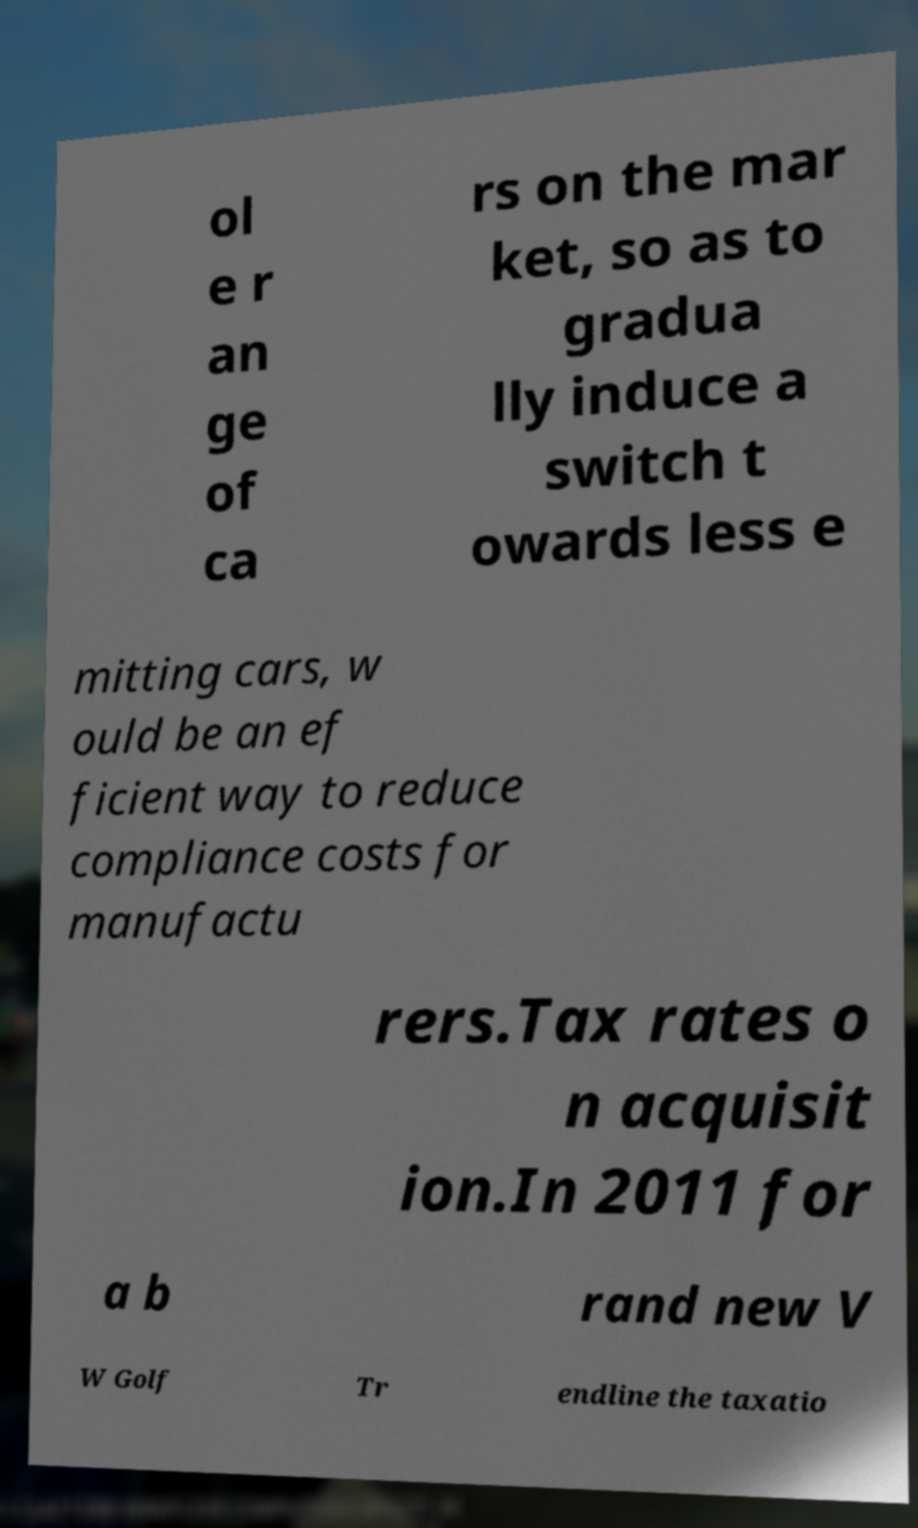Can you read and provide the text displayed in the image?This photo seems to have some interesting text. Can you extract and type it out for me? ol e r an ge of ca rs on the mar ket, so as to gradua lly induce a switch t owards less e mitting cars, w ould be an ef ficient way to reduce compliance costs for manufactu rers.Tax rates o n acquisit ion.In 2011 for a b rand new V W Golf Tr endline the taxatio 